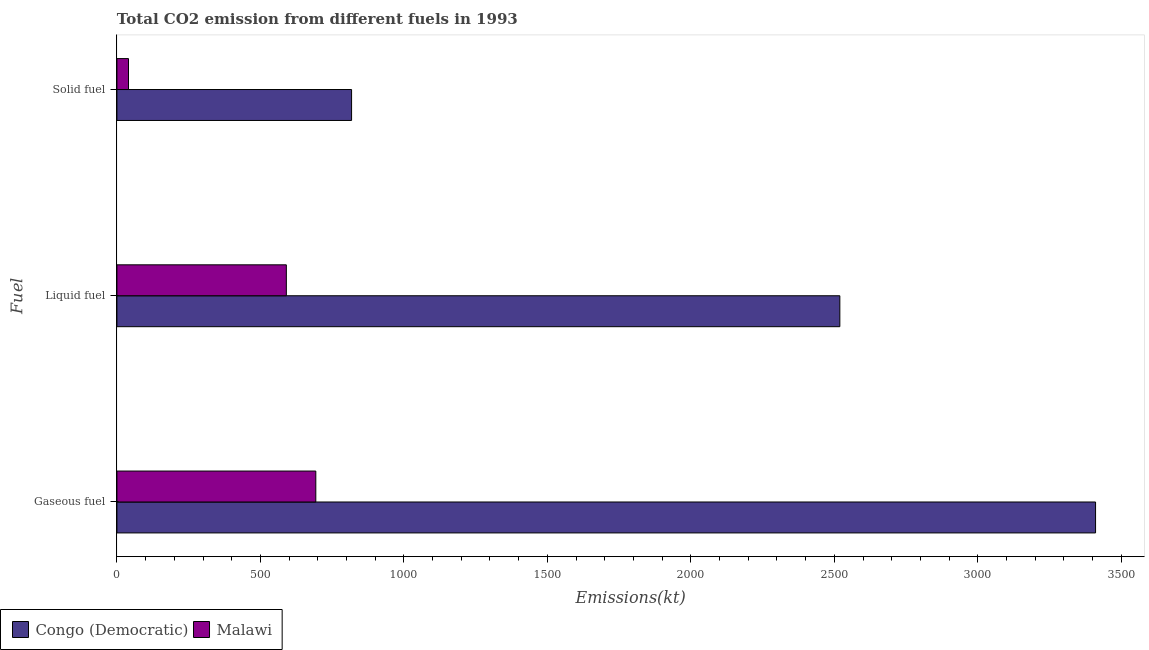How many groups of bars are there?
Your response must be concise. 3. Are the number of bars per tick equal to the number of legend labels?
Provide a succinct answer. Yes. How many bars are there on the 3rd tick from the bottom?
Your response must be concise. 2. What is the label of the 2nd group of bars from the top?
Give a very brief answer. Liquid fuel. What is the amount of co2 emissions from liquid fuel in Congo (Democratic)?
Your answer should be very brief. 2519.23. Across all countries, what is the maximum amount of co2 emissions from gaseous fuel?
Give a very brief answer. 3410.31. Across all countries, what is the minimum amount of co2 emissions from liquid fuel?
Your response must be concise. 590.39. In which country was the amount of co2 emissions from gaseous fuel maximum?
Make the answer very short. Congo (Democratic). In which country was the amount of co2 emissions from solid fuel minimum?
Your answer should be compact. Malawi. What is the total amount of co2 emissions from liquid fuel in the graph?
Offer a terse response. 3109.62. What is the difference between the amount of co2 emissions from solid fuel in Malawi and that in Congo (Democratic)?
Your answer should be compact. -777.4. What is the difference between the amount of co2 emissions from solid fuel in Congo (Democratic) and the amount of co2 emissions from liquid fuel in Malawi?
Keep it short and to the point. 227.35. What is the average amount of co2 emissions from gaseous fuel per country?
Your response must be concise. 2051.69. What is the difference between the amount of co2 emissions from liquid fuel and amount of co2 emissions from gaseous fuel in Malawi?
Give a very brief answer. -102.68. In how many countries, is the amount of co2 emissions from gaseous fuel greater than 2200 kt?
Ensure brevity in your answer.  1. What is the ratio of the amount of co2 emissions from liquid fuel in Congo (Democratic) to that in Malawi?
Make the answer very short. 4.27. Is the amount of co2 emissions from liquid fuel in Malawi less than that in Congo (Democratic)?
Give a very brief answer. Yes. Is the difference between the amount of co2 emissions from solid fuel in Congo (Democratic) and Malawi greater than the difference between the amount of co2 emissions from gaseous fuel in Congo (Democratic) and Malawi?
Your answer should be compact. No. What is the difference between the highest and the second highest amount of co2 emissions from liquid fuel?
Your answer should be compact. 1928.84. What is the difference between the highest and the lowest amount of co2 emissions from gaseous fuel?
Your answer should be very brief. 2717.25. In how many countries, is the amount of co2 emissions from gaseous fuel greater than the average amount of co2 emissions from gaseous fuel taken over all countries?
Provide a succinct answer. 1. Is the sum of the amount of co2 emissions from liquid fuel in Malawi and Congo (Democratic) greater than the maximum amount of co2 emissions from gaseous fuel across all countries?
Offer a very short reply. No. What does the 1st bar from the top in Liquid fuel represents?
Provide a short and direct response. Malawi. What does the 1st bar from the bottom in Liquid fuel represents?
Provide a succinct answer. Congo (Democratic). Are all the bars in the graph horizontal?
Provide a succinct answer. Yes. How many countries are there in the graph?
Make the answer very short. 2. What is the difference between two consecutive major ticks on the X-axis?
Provide a succinct answer. 500. Are the values on the major ticks of X-axis written in scientific E-notation?
Give a very brief answer. No. Does the graph contain any zero values?
Make the answer very short. No. Does the graph contain grids?
Keep it short and to the point. No. How many legend labels are there?
Your response must be concise. 2. What is the title of the graph?
Give a very brief answer. Total CO2 emission from different fuels in 1993. What is the label or title of the X-axis?
Ensure brevity in your answer.  Emissions(kt). What is the label or title of the Y-axis?
Provide a succinct answer. Fuel. What is the Emissions(kt) of Congo (Democratic) in Gaseous fuel?
Provide a short and direct response. 3410.31. What is the Emissions(kt) of Malawi in Gaseous fuel?
Ensure brevity in your answer.  693.06. What is the Emissions(kt) of Congo (Democratic) in Liquid fuel?
Give a very brief answer. 2519.23. What is the Emissions(kt) in Malawi in Liquid fuel?
Your answer should be very brief. 590.39. What is the Emissions(kt) of Congo (Democratic) in Solid fuel?
Offer a terse response. 817.74. What is the Emissions(kt) of Malawi in Solid fuel?
Provide a succinct answer. 40.34. Across all Fuel, what is the maximum Emissions(kt) of Congo (Democratic)?
Make the answer very short. 3410.31. Across all Fuel, what is the maximum Emissions(kt) of Malawi?
Your answer should be very brief. 693.06. Across all Fuel, what is the minimum Emissions(kt) in Congo (Democratic)?
Your answer should be compact. 817.74. Across all Fuel, what is the minimum Emissions(kt) of Malawi?
Offer a very short reply. 40.34. What is the total Emissions(kt) in Congo (Democratic) in the graph?
Give a very brief answer. 6747.28. What is the total Emissions(kt) in Malawi in the graph?
Your answer should be compact. 1323.79. What is the difference between the Emissions(kt) in Congo (Democratic) in Gaseous fuel and that in Liquid fuel?
Your answer should be very brief. 891.08. What is the difference between the Emissions(kt) in Malawi in Gaseous fuel and that in Liquid fuel?
Give a very brief answer. 102.68. What is the difference between the Emissions(kt) of Congo (Democratic) in Gaseous fuel and that in Solid fuel?
Ensure brevity in your answer.  2592.57. What is the difference between the Emissions(kt) of Malawi in Gaseous fuel and that in Solid fuel?
Your answer should be compact. 652.73. What is the difference between the Emissions(kt) in Congo (Democratic) in Liquid fuel and that in Solid fuel?
Provide a succinct answer. 1701.49. What is the difference between the Emissions(kt) of Malawi in Liquid fuel and that in Solid fuel?
Provide a short and direct response. 550.05. What is the difference between the Emissions(kt) in Congo (Democratic) in Gaseous fuel and the Emissions(kt) in Malawi in Liquid fuel?
Offer a very short reply. 2819.92. What is the difference between the Emissions(kt) in Congo (Democratic) in Gaseous fuel and the Emissions(kt) in Malawi in Solid fuel?
Keep it short and to the point. 3369.97. What is the difference between the Emissions(kt) of Congo (Democratic) in Liquid fuel and the Emissions(kt) of Malawi in Solid fuel?
Offer a terse response. 2478.89. What is the average Emissions(kt) of Congo (Democratic) per Fuel?
Provide a succinct answer. 2249.09. What is the average Emissions(kt) of Malawi per Fuel?
Your answer should be very brief. 441.26. What is the difference between the Emissions(kt) in Congo (Democratic) and Emissions(kt) in Malawi in Gaseous fuel?
Keep it short and to the point. 2717.25. What is the difference between the Emissions(kt) of Congo (Democratic) and Emissions(kt) of Malawi in Liquid fuel?
Your answer should be very brief. 1928.84. What is the difference between the Emissions(kt) in Congo (Democratic) and Emissions(kt) in Malawi in Solid fuel?
Keep it short and to the point. 777.4. What is the ratio of the Emissions(kt) of Congo (Democratic) in Gaseous fuel to that in Liquid fuel?
Provide a short and direct response. 1.35. What is the ratio of the Emissions(kt) in Malawi in Gaseous fuel to that in Liquid fuel?
Provide a short and direct response. 1.17. What is the ratio of the Emissions(kt) of Congo (Democratic) in Gaseous fuel to that in Solid fuel?
Offer a very short reply. 4.17. What is the ratio of the Emissions(kt) of Malawi in Gaseous fuel to that in Solid fuel?
Provide a succinct answer. 17.18. What is the ratio of the Emissions(kt) in Congo (Democratic) in Liquid fuel to that in Solid fuel?
Your answer should be very brief. 3.08. What is the ratio of the Emissions(kt) of Malawi in Liquid fuel to that in Solid fuel?
Keep it short and to the point. 14.64. What is the difference between the highest and the second highest Emissions(kt) of Congo (Democratic)?
Provide a short and direct response. 891.08. What is the difference between the highest and the second highest Emissions(kt) in Malawi?
Make the answer very short. 102.68. What is the difference between the highest and the lowest Emissions(kt) in Congo (Democratic)?
Give a very brief answer. 2592.57. What is the difference between the highest and the lowest Emissions(kt) of Malawi?
Provide a short and direct response. 652.73. 